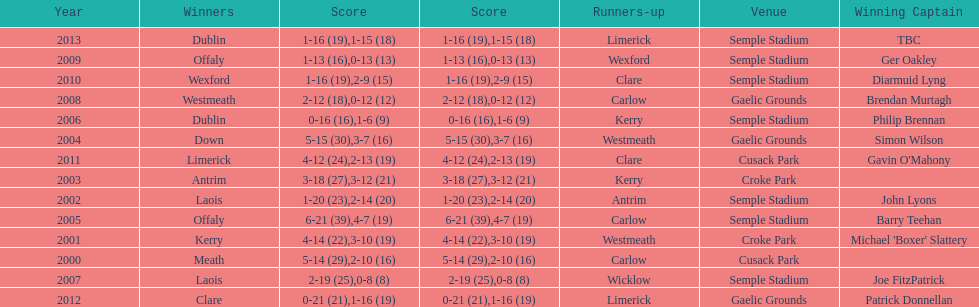Would you be able to parse every entry in this table? {'header': ['Year', 'Winners', 'Score', 'Score', 'Runners-up', 'Venue', 'Winning Captain'], 'rows': [['2013', 'Dublin', '1-16 (19)', '1-15 (18)', 'Limerick', 'Semple Stadium', 'TBC'], ['2009', 'Offaly', '1-13 (16)', '0-13 (13)', 'Wexford', 'Semple Stadium', 'Ger Oakley'], ['2010', 'Wexford', '1-16 (19)', '2-9 (15)', 'Clare', 'Semple Stadium', 'Diarmuid Lyng'], ['2008', 'Westmeath', '2-12 (18)', '0-12 (12)', 'Carlow', 'Gaelic Grounds', 'Brendan Murtagh'], ['2006', 'Dublin', '0-16 (16)', '1-6 (9)', 'Kerry', 'Semple Stadium', 'Philip Brennan'], ['2004', 'Down', '5-15 (30)', '3-7 (16)', 'Westmeath', 'Gaelic Grounds', 'Simon Wilson'], ['2011', 'Limerick', '4-12 (24)', '2-13 (19)', 'Clare', 'Cusack Park', "Gavin O'Mahony"], ['2003', 'Antrim', '3-18 (27)', '3-12 (21)', 'Kerry', 'Croke Park', ''], ['2002', 'Laois', '1-20 (23)', '2-14 (20)', 'Antrim', 'Semple Stadium', 'John Lyons'], ['2005', 'Offaly', '6-21 (39)', '4-7 (19)', 'Carlow', 'Semple Stadium', 'Barry Teehan'], ['2001', 'Kerry', '4-14 (22)', '3-10 (19)', 'Westmeath', 'Croke Park', "Michael 'Boxer' Slattery"], ['2000', 'Meath', '5-14 (29)', '2-10 (16)', 'Carlow', 'Cusack Park', ''], ['2007', 'Laois', '2-19 (25)', '0-8 (8)', 'Wicklow', 'Semple Stadium', 'Joe FitzPatrick'], ['2012', 'Clare', '0-21 (21)', '1-16 (19)', 'Limerick', 'Gaelic Grounds', 'Patrick Donnellan']]} How many winners won in semple stadium? 7. 